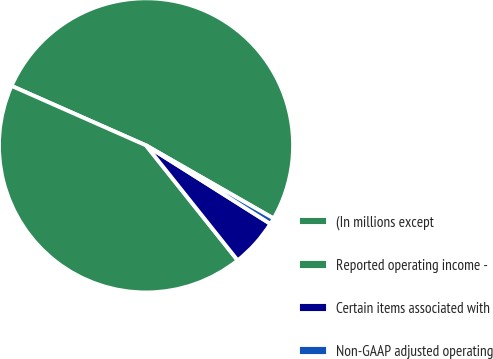<chart> <loc_0><loc_0><loc_500><loc_500><pie_chart><fcel>(In millions except<fcel>Reported operating income -<fcel>Certain items associated with<fcel>Non-GAAP adjusted operating<nl><fcel>51.65%<fcel>42.34%<fcel>5.33%<fcel>0.68%<nl></chart> 